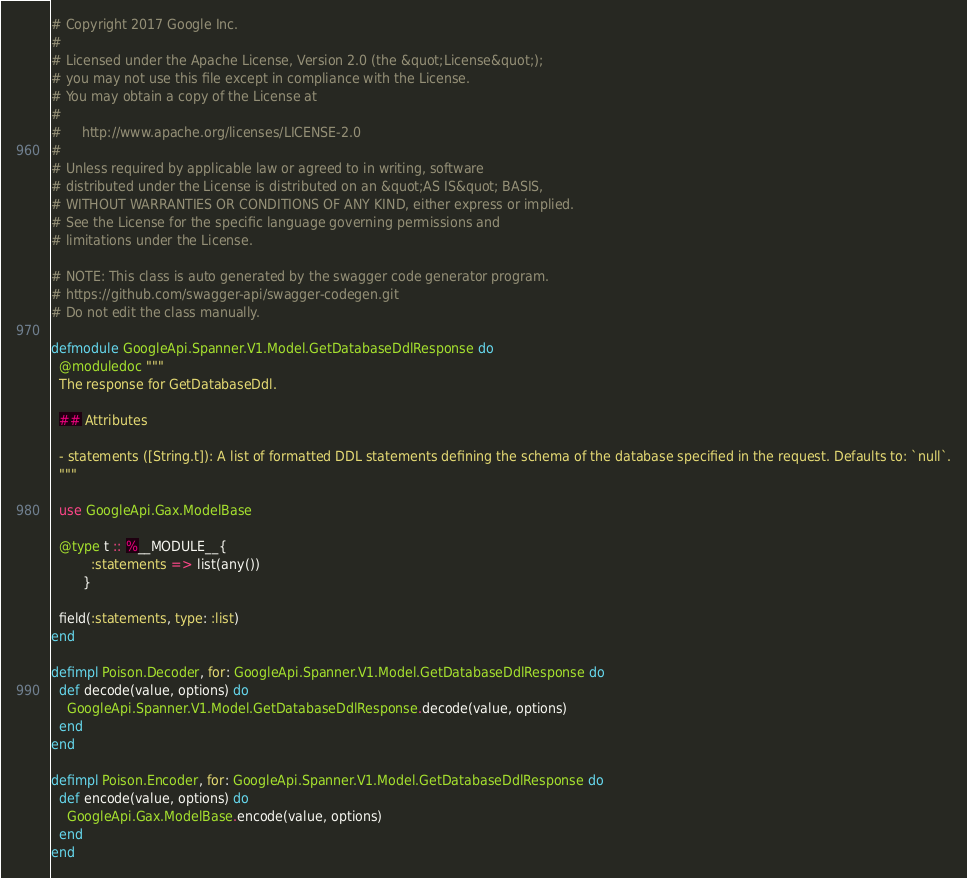<code> <loc_0><loc_0><loc_500><loc_500><_Elixir_># Copyright 2017 Google Inc.
#
# Licensed under the Apache License, Version 2.0 (the &quot;License&quot;);
# you may not use this file except in compliance with the License.
# You may obtain a copy of the License at
#
#     http://www.apache.org/licenses/LICENSE-2.0
#
# Unless required by applicable law or agreed to in writing, software
# distributed under the License is distributed on an &quot;AS IS&quot; BASIS,
# WITHOUT WARRANTIES OR CONDITIONS OF ANY KIND, either express or implied.
# See the License for the specific language governing permissions and
# limitations under the License.

# NOTE: This class is auto generated by the swagger code generator program.
# https://github.com/swagger-api/swagger-codegen.git
# Do not edit the class manually.

defmodule GoogleApi.Spanner.V1.Model.GetDatabaseDdlResponse do
  @moduledoc """
  The response for GetDatabaseDdl.

  ## Attributes

  - statements ([String.t]): A list of formatted DDL statements defining the schema of the database specified in the request. Defaults to: `null`.
  """

  use GoogleApi.Gax.ModelBase

  @type t :: %__MODULE__{
          :statements => list(any())
        }

  field(:statements, type: :list)
end

defimpl Poison.Decoder, for: GoogleApi.Spanner.V1.Model.GetDatabaseDdlResponse do
  def decode(value, options) do
    GoogleApi.Spanner.V1.Model.GetDatabaseDdlResponse.decode(value, options)
  end
end

defimpl Poison.Encoder, for: GoogleApi.Spanner.V1.Model.GetDatabaseDdlResponse do
  def encode(value, options) do
    GoogleApi.Gax.ModelBase.encode(value, options)
  end
end
</code> 